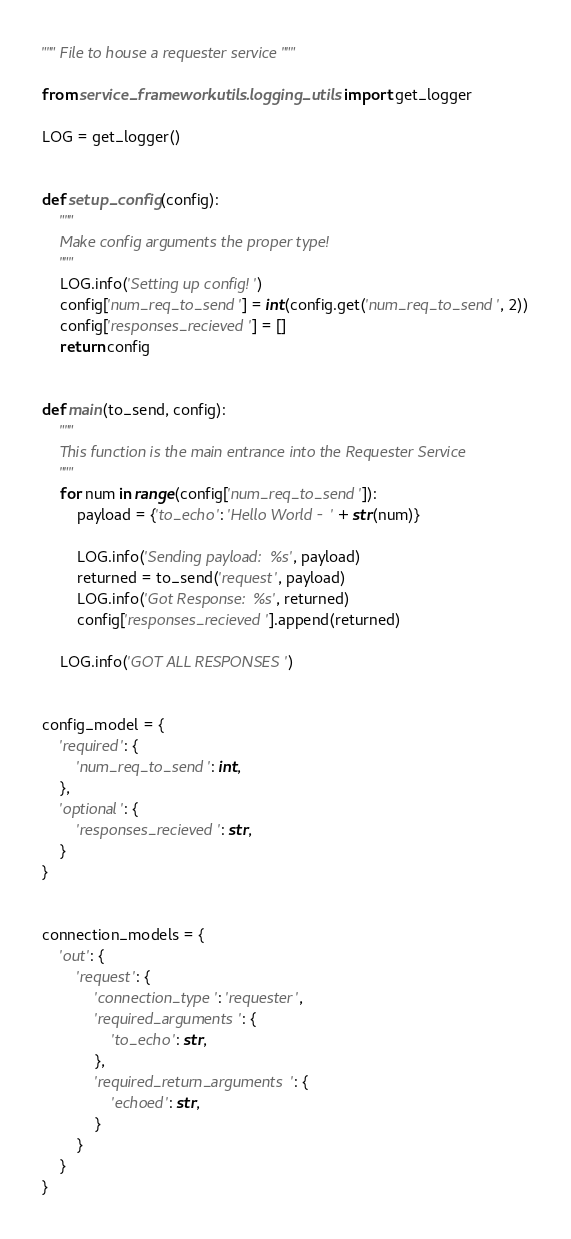<code> <loc_0><loc_0><loc_500><loc_500><_Python_>""" File to house a requester service """

from service_framework.utils.logging_utils import get_logger

LOG = get_logger()


def setup_config(config):
    """
    Make config arguments the proper type!
    """
    LOG.info('Setting up config!')
    config['num_req_to_send'] = int(config.get('num_req_to_send', 2))
    config['responses_recieved'] = []
    return config


def main(to_send, config):
    """
    This function is the main entrance into the Requester Service
    """
    for num in range(config['num_req_to_send']):
        payload = {'to_echo': 'Hello World - ' + str(num)}

        LOG.info('Sending payload: %s', payload)
        returned = to_send('request', payload)
        LOG.info('Got Response: %s', returned)
        config['responses_recieved'].append(returned)

    LOG.info('GOT ALL RESPONSES')


config_model = {
    'required': {
        'num_req_to_send': int,
    },
    'optional': {
        'responses_recieved': str,
    }
}


connection_models = {
    'out': {
        'request': {
            'connection_type': 'requester',
            'required_arguments': {
                'to_echo': str,
            },
            'required_return_arguments': {
                'echoed': str,
            }
        }
    }
}
</code> 